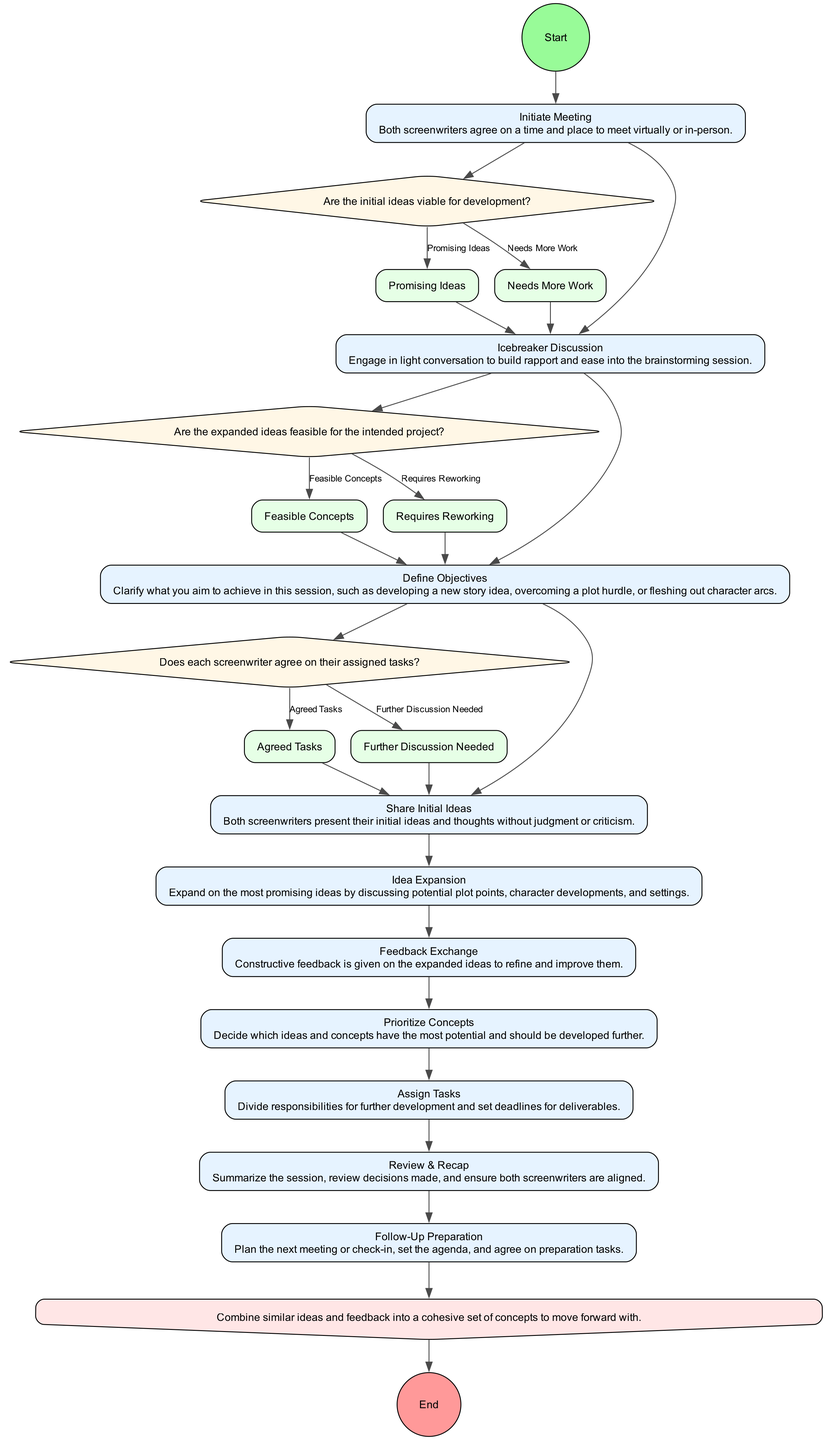What is the first activity in the diagram? The diagram starts with the node labeled "Initiate Meeting," indicating that this is the first activity where both screenwriters agree on a time and place to meet.
Answer: Initiate Meeting How many activities are present in the diagram? By counting all the activity nodes, there are a total of 10 activities listed, starting from "Initiate Meeting" to "Follow-Up Preparation."
Answer: 10 What is the outcome of the "Feedback Exchange" activity? The "Feedback Exchange" activity has two outcomes listed: "Refined Ideas" and "Consolidated Concepts," which describe the results of giving constructive feedback.
Answer: Refined Ideas, Consolidated Concepts What question is asked during the decision after "Share Initial Ideas"? The decision node following "Share Initial Ideas" asks, "Are the initial ideas viable for development?" which assesses the viability of the ideas presented by the screenwriters.
Answer: Are the initial ideas viable for development? What happens after the "Prioritize Concepts" activity? After completing "Prioritize Concepts," the next step involves assigning tasks that have been agreed upon, establishing responsibilities for further work.
Answer: Assign Tasks How are similar ideas consolidated in the diagram? The diagram contains a merge node labeled "Idea Consolidation," which describes the process of combining similar ideas and feedback into a unified set of concepts for further development.
Answer: Unified Concepts What is the final outcome of the diagram? The final output of the diagram is indicated by the "End" node, representing the conclusion of the brainstorming session and the completion of all outlined activities.
Answer: End What decision follows the "Assign Tasks" activity? The decision that immediately follows "Assign Tasks" is about task delegation, specifically asking, "Does each screenwriter agree on their assigned tasks?" which checks for consensus on the tasks assigned.
Answer: Does each screenwriter agree on their assigned tasks? What type of atmosphere is aimed for during the "Icebreaker Discussion"? The "Icebreaker Discussion" aims to create a "Comfortable Atmosphere," allowing both screenwriters to connect before diving into the brainstorming session.
Answer: Comfortable Atmosphere What is the outcome of the "Define Objectives" activity? The outcome of the "Define Objectives" activity is "Clear Objectives," indicating that both writers have established what they wish to accomplish in the session.
Answer: Clear Objectives 